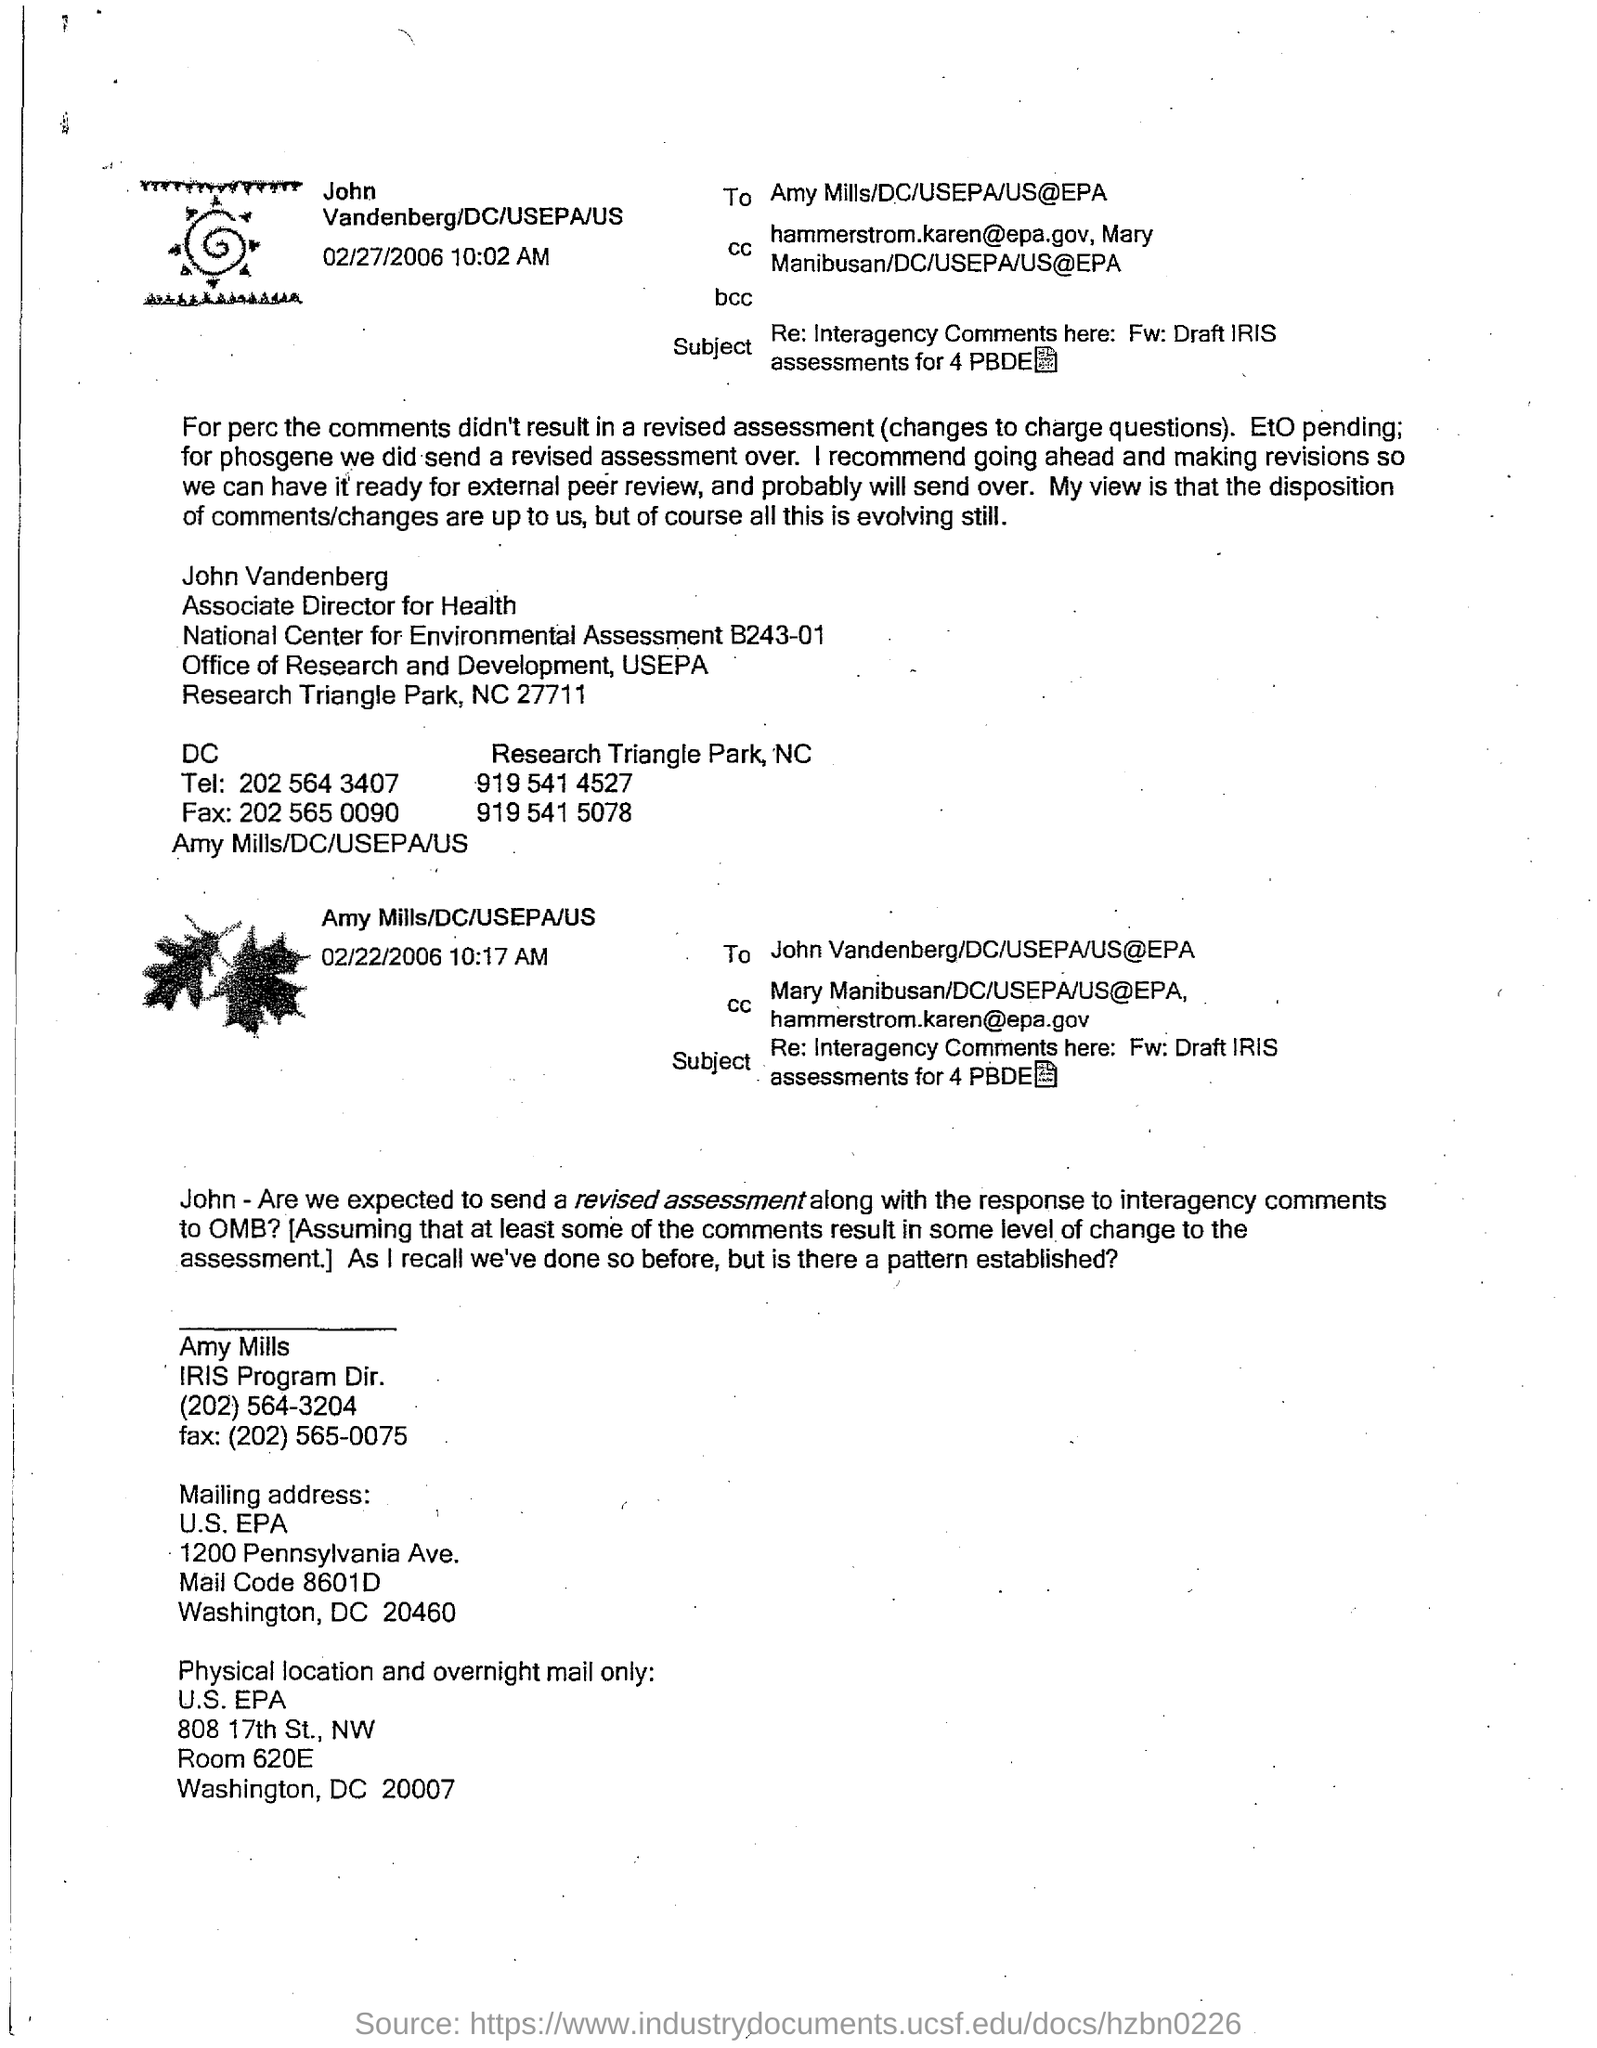Indicate a few pertinent items in this graphic. The Associate Director for Health is named John. The date and time mentioned in the top left image is February 27, 2006 at 10:02 AM. The mailing address of "Amy Mills" includes a mail code of 8601D. Amy Mills is the designation of an individual who holds the position of IRIS Program Director. The FAX number of John Vandenberg at the Department of Commerce is 202 565 0090. 